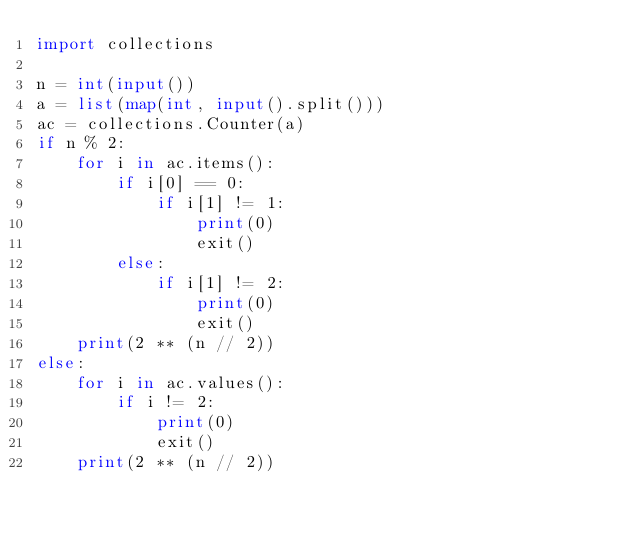Convert code to text. <code><loc_0><loc_0><loc_500><loc_500><_Python_>import collections

n = int(input())
a = list(map(int, input().split()))
ac = collections.Counter(a)
if n % 2:
    for i in ac.items():
        if i[0] == 0:
            if i[1] != 1:
                print(0)
                exit()
        else:
            if i[1] != 2:
                print(0)
                exit()
    print(2 ** (n // 2))
else:
    for i in ac.values():
        if i != 2:
            print(0)
            exit()
    print(2 ** (n // 2))</code> 